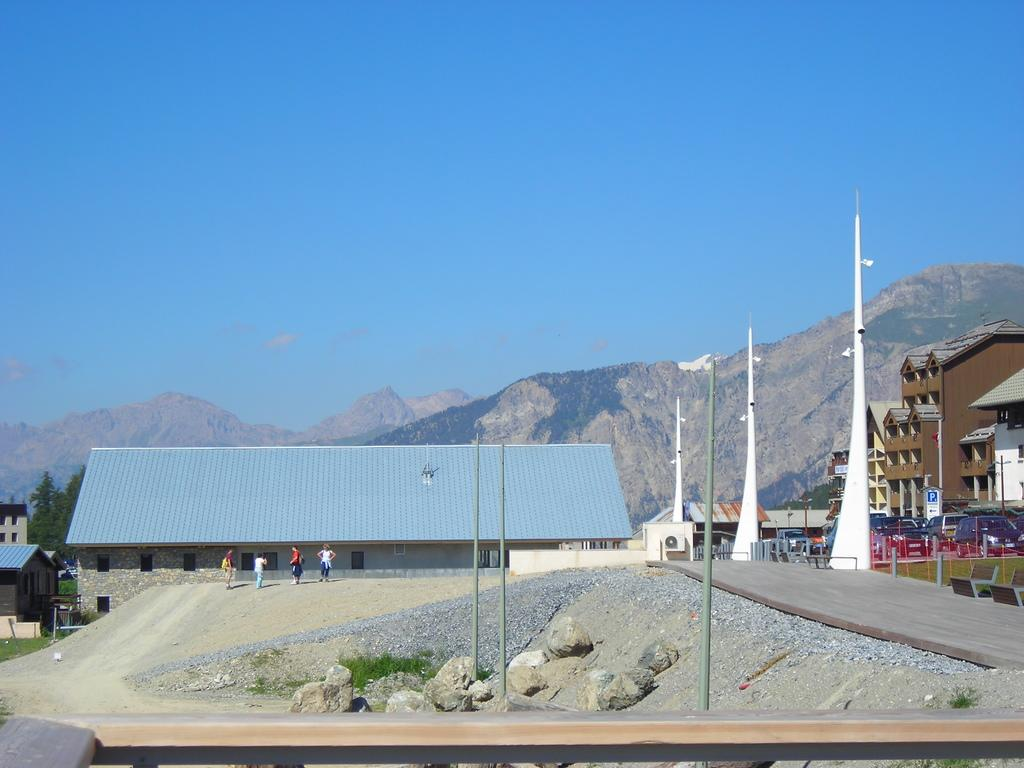What type of geographical feature is present in the image? There is a hill in the image. What can be seen in the sky in the image? The sky is visible in the image. What type of structures are present in the image? There are buildings in the image. Are there any people visible in the image? Yes, there are persons in the image. What type of pathway is present in the image? There is a road in the image. What type of vertical structures are present in the image? There are poles in the image. What type of transportation is present in the image? There are vehicles in the image. What type of vegetation is present in the image? There are trees in the image. What type of natural feature is present in the image? There are stones in the image. How many crows are sitting on the hill in the image? There are no crows present in the image. What color are the eyes of the persons in the image? The image does not show the eyes of the persons, so it cannot be determined. 